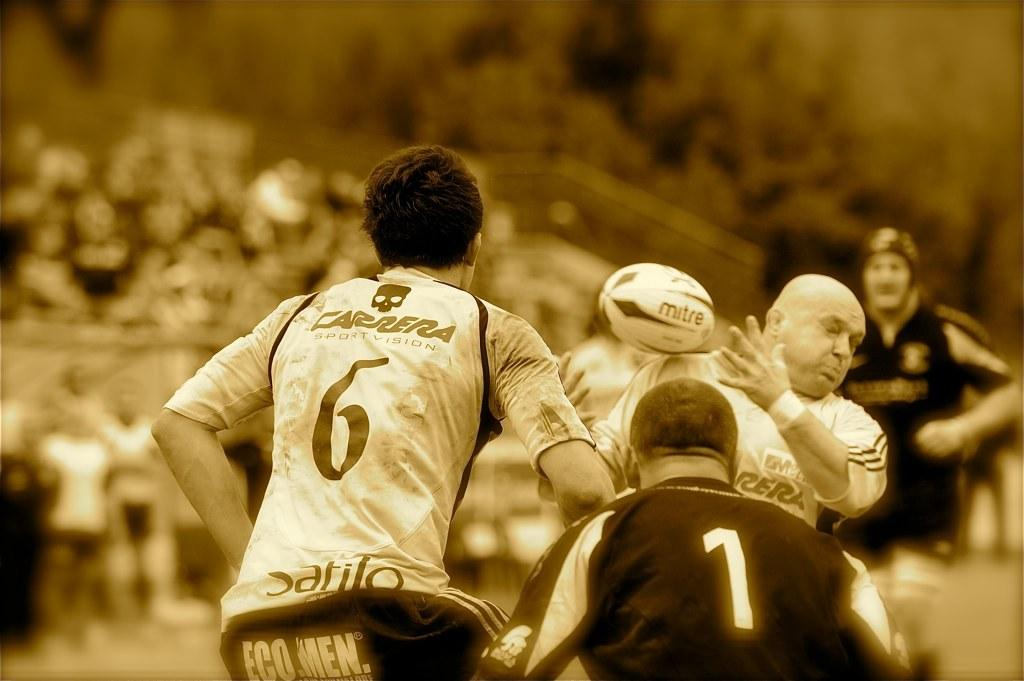Provide a one-sentence caption for the provided image. a sepia picture of rugby, with one man wearing a number 6 shirt and one a number 1. 